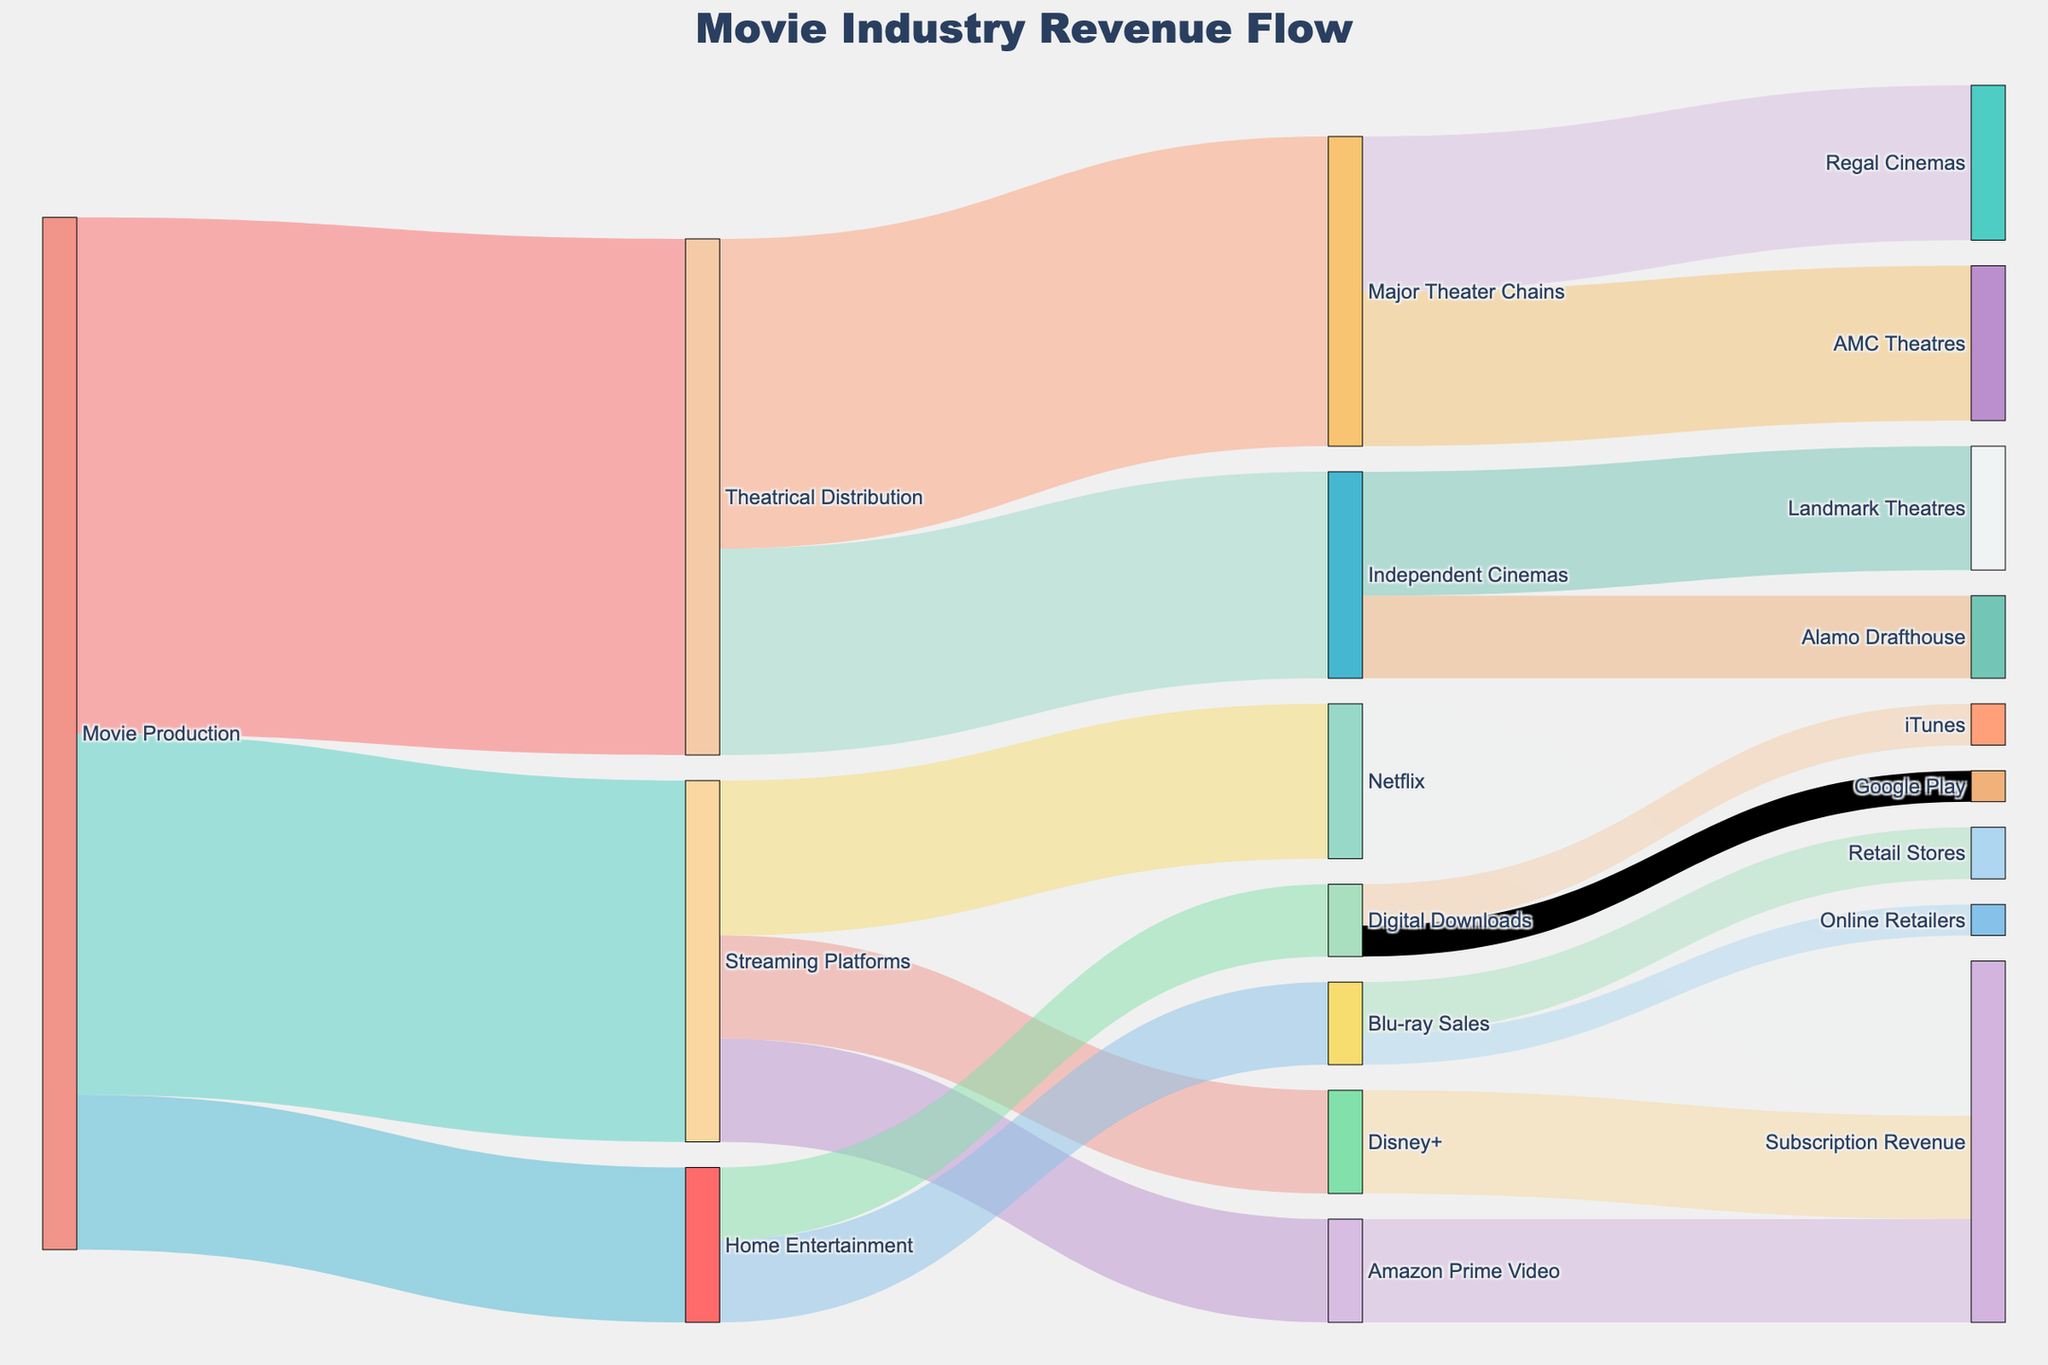What is the title of the figure? The title is placed at the top of the figure and describes the overall theme or subject.
Answer: Movie Industry Revenue Flow How many distinct sources are represented in the diagram? Count the number of unique starting points from which arrows originate. The distinct sources are "Movie Production," "Theatrical Distribution," "Streaming Platforms," and "Home Entertainment."
Answer: 4 Which distribution channel receives the highest revenue from movie production? Look at the arrows emanating from "Movie Production" and identify which has the largest value. "Theatrical Distribution" receives 5000, "Streaming Platforms" receives 3500, and "Home Entertainment" receives 1500.
Answer: Theatrical Distribution What is the total revenue flowing into Streaming Platforms? Sum the values of all arrows pointing to "Streaming Platforms."
Answer: 3500 Compare the revenue flow from "Theatrical Distribution" to "Major Theater Chains" and "Independent Cinemas." Which is greater? Look for the values of the arrows going from "Theatrical Distribution" to "Major Theater Chains" (3000) and to "Independent Cinemas" (2000). Compare these values.
Answer: Major Theater Chains List all the end targets (nodes without further outgoing arrows) in the diagram. Identify nodes that do not have any arrows leading away from them. These end targets are "Subscription Revenue," "Retail Stores," "Online Retailers," "iTunes," and "Google Play."
Answer: Subscription Revenue, Retail Stores, Online Retailers, iTunes, Google Play What percentage of the total revenue from "Home Entertainment" comes from "Blu-ray Sales"? Calculate the sum of values from "Home Entertainment" (800 + 700 = 1500). Then, compute the percentage of "Blu-ray Sales" (800/1500 * 100).
Answer: 53.33% What is the cumulative revenue flow into major theater chains (AMC Theatres and Regal Cinemas)? Add the revenue flow values for "AMC Theatres" (1500) and "Regal Cinemas" (1500).
Answer: 3000 Compare the revenue flows to "Netflix," "Amazon Prime Video," and "Disney+." Which platform has the least revenue flow? Look at the arrows pointing to each platform: "Netflix" (1500), "Amazon Prime Video" (1000), "Disney+" (1000). Compare these values.
Answer: Amazon Prime Video and Disney+ What portion of the "Digital Downloads" revenue comes from "iTunes"? The total value for "Digital Downloads" is 700, and the value from "iTunes" is 400. Calculate the portion (400/700).
Answer: 0.57 (or 57%) 